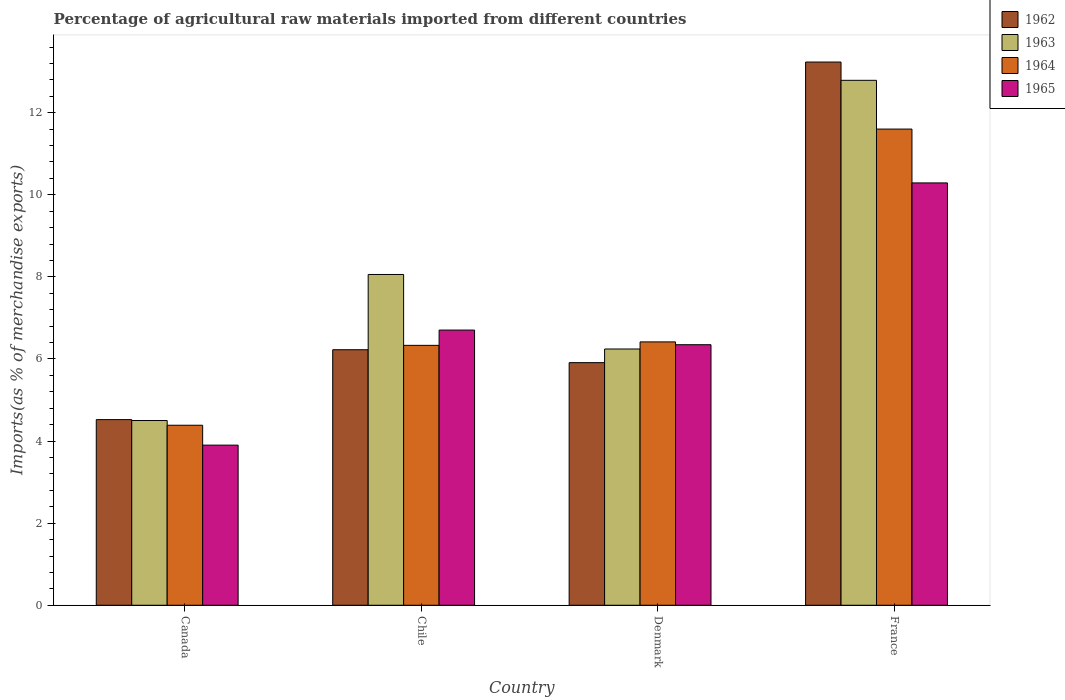Are the number of bars per tick equal to the number of legend labels?
Your answer should be compact. Yes. Are the number of bars on each tick of the X-axis equal?
Your answer should be very brief. Yes. How many bars are there on the 3rd tick from the left?
Your response must be concise. 4. What is the percentage of imports to different countries in 1965 in Chile?
Give a very brief answer. 6.7. Across all countries, what is the maximum percentage of imports to different countries in 1965?
Ensure brevity in your answer.  10.29. Across all countries, what is the minimum percentage of imports to different countries in 1964?
Your answer should be compact. 4.39. What is the total percentage of imports to different countries in 1962 in the graph?
Provide a succinct answer. 29.9. What is the difference between the percentage of imports to different countries in 1962 in Chile and that in Denmark?
Your answer should be very brief. 0.31. What is the difference between the percentage of imports to different countries in 1965 in France and the percentage of imports to different countries in 1964 in Chile?
Your response must be concise. 3.96. What is the average percentage of imports to different countries in 1965 per country?
Ensure brevity in your answer.  6.81. What is the difference between the percentage of imports to different countries of/in 1963 and percentage of imports to different countries of/in 1964 in France?
Your answer should be compact. 1.19. What is the ratio of the percentage of imports to different countries in 1962 in Chile to that in Denmark?
Provide a succinct answer. 1.05. Is the percentage of imports to different countries in 1963 in Denmark less than that in France?
Your answer should be compact. Yes. What is the difference between the highest and the second highest percentage of imports to different countries in 1965?
Keep it short and to the point. 3.59. What is the difference between the highest and the lowest percentage of imports to different countries in 1964?
Your answer should be very brief. 7.22. In how many countries, is the percentage of imports to different countries in 1964 greater than the average percentage of imports to different countries in 1964 taken over all countries?
Keep it short and to the point. 1. What does the 4th bar from the left in France represents?
Offer a terse response. 1965. What does the 2nd bar from the right in Chile represents?
Provide a short and direct response. 1964. How many bars are there?
Your answer should be very brief. 16. What is the difference between two consecutive major ticks on the Y-axis?
Your answer should be very brief. 2. Does the graph contain grids?
Offer a very short reply. No. Where does the legend appear in the graph?
Make the answer very short. Top right. What is the title of the graph?
Offer a terse response. Percentage of agricultural raw materials imported from different countries. What is the label or title of the X-axis?
Your answer should be very brief. Country. What is the label or title of the Y-axis?
Offer a terse response. Imports(as % of merchandise exports). What is the Imports(as % of merchandise exports) in 1962 in Canada?
Your answer should be very brief. 4.52. What is the Imports(as % of merchandise exports) of 1963 in Canada?
Your response must be concise. 4.5. What is the Imports(as % of merchandise exports) of 1964 in Canada?
Offer a very short reply. 4.39. What is the Imports(as % of merchandise exports) of 1965 in Canada?
Make the answer very short. 3.9. What is the Imports(as % of merchandise exports) of 1962 in Chile?
Provide a short and direct response. 6.23. What is the Imports(as % of merchandise exports) in 1963 in Chile?
Give a very brief answer. 8.06. What is the Imports(as % of merchandise exports) of 1964 in Chile?
Provide a short and direct response. 6.33. What is the Imports(as % of merchandise exports) of 1965 in Chile?
Provide a succinct answer. 6.7. What is the Imports(as % of merchandise exports) in 1962 in Denmark?
Give a very brief answer. 5.91. What is the Imports(as % of merchandise exports) of 1963 in Denmark?
Your answer should be very brief. 6.24. What is the Imports(as % of merchandise exports) in 1964 in Denmark?
Give a very brief answer. 6.42. What is the Imports(as % of merchandise exports) in 1965 in Denmark?
Make the answer very short. 6.35. What is the Imports(as % of merchandise exports) of 1962 in France?
Ensure brevity in your answer.  13.24. What is the Imports(as % of merchandise exports) of 1963 in France?
Offer a terse response. 12.79. What is the Imports(as % of merchandise exports) in 1964 in France?
Your response must be concise. 11.6. What is the Imports(as % of merchandise exports) of 1965 in France?
Ensure brevity in your answer.  10.29. Across all countries, what is the maximum Imports(as % of merchandise exports) in 1962?
Your answer should be very brief. 13.24. Across all countries, what is the maximum Imports(as % of merchandise exports) of 1963?
Provide a succinct answer. 12.79. Across all countries, what is the maximum Imports(as % of merchandise exports) in 1964?
Provide a succinct answer. 11.6. Across all countries, what is the maximum Imports(as % of merchandise exports) of 1965?
Give a very brief answer. 10.29. Across all countries, what is the minimum Imports(as % of merchandise exports) of 1962?
Your response must be concise. 4.52. Across all countries, what is the minimum Imports(as % of merchandise exports) in 1963?
Give a very brief answer. 4.5. Across all countries, what is the minimum Imports(as % of merchandise exports) in 1964?
Your answer should be compact. 4.39. Across all countries, what is the minimum Imports(as % of merchandise exports) in 1965?
Make the answer very short. 3.9. What is the total Imports(as % of merchandise exports) in 1962 in the graph?
Offer a terse response. 29.9. What is the total Imports(as % of merchandise exports) of 1963 in the graph?
Your response must be concise. 31.59. What is the total Imports(as % of merchandise exports) of 1964 in the graph?
Your response must be concise. 28.74. What is the total Imports(as % of merchandise exports) of 1965 in the graph?
Your answer should be very brief. 27.24. What is the difference between the Imports(as % of merchandise exports) in 1962 in Canada and that in Chile?
Keep it short and to the point. -1.7. What is the difference between the Imports(as % of merchandise exports) of 1963 in Canada and that in Chile?
Your answer should be very brief. -3.56. What is the difference between the Imports(as % of merchandise exports) in 1964 in Canada and that in Chile?
Make the answer very short. -1.95. What is the difference between the Imports(as % of merchandise exports) in 1965 in Canada and that in Chile?
Your answer should be compact. -2.8. What is the difference between the Imports(as % of merchandise exports) of 1962 in Canada and that in Denmark?
Offer a very short reply. -1.39. What is the difference between the Imports(as % of merchandise exports) of 1963 in Canada and that in Denmark?
Ensure brevity in your answer.  -1.74. What is the difference between the Imports(as % of merchandise exports) in 1964 in Canada and that in Denmark?
Provide a short and direct response. -2.03. What is the difference between the Imports(as % of merchandise exports) of 1965 in Canada and that in Denmark?
Provide a succinct answer. -2.45. What is the difference between the Imports(as % of merchandise exports) in 1962 in Canada and that in France?
Provide a short and direct response. -8.71. What is the difference between the Imports(as % of merchandise exports) in 1963 in Canada and that in France?
Your answer should be compact. -8.29. What is the difference between the Imports(as % of merchandise exports) in 1964 in Canada and that in France?
Your answer should be very brief. -7.22. What is the difference between the Imports(as % of merchandise exports) of 1965 in Canada and that in France?
Your response must be concise. -6.39. What is the difference between the Imports(as % of merchandise exports) in 1962 in Chile and that in Denmark?
Provide a succinct answer. 0.31. What is the difference between the Imports(as % of merchandise exports) in 1963 in Chile and that in Denmark?
Keep it short and to the point. 1.82. What is the difference between the Imports(as % of merchandise exports) of 1964 in Chile and that in Denmark?
Provide a short and direct response. -0.08. What is the difference between the Imports(as % of merchandise exports) of 1965 in Chile and that in Denmark?
Offer a terse response. 0.36. What is the difference between the Imports(as % of merchandise exports) of 1962 in Chile and that in France?
Ensure brevity in your answer.  -7.01. What is the difference between the Imports(as % of merchandise exports) in 1963 in Chile and that in France?
Ensure brevity in your answer.  -4.73. What is the difference between the Imports(as % of merchandise exports) of 1964 in Chile and that in France?
Give a very brief answer. -5.27. What is the difference between the Imports(as % of merchandise exports) in 1965 in Chile and that in France?
Your response must be concise. -3.59. What is the difference between the Imports(as % of merchandise exports) of 1962 in Denmark and that in France?
Offer a very short reply. -7.32. What is the difference between the Imports(as % of merchandise exports) in 1963 in Denmark and that in France?
Provide a short and direct response. -6.55. What is the difference between the Imports(as % of merchandise exports) of 1964 in Denmark and that in France?
Your answer should be very brief. -5.19. What is the difference between the Imports(as % of merchandise exports) of 1965 in Denmark and that in France?
Your answer should be compact. -3.94. What is the difference between the Imports(as % of merchandise exports) of 1962 in Canada and the Imports(as % of merchandise exports) of 1963 in Chile?
Keep it short and to the point. -3.54. What is the difference between the Imports(as % of merchandise exports) in 1962 in Canada and the Imports(as % of merchandise exports) in 1964 in Chile?
Your response must be concise. -1.81. What is the difference between the Imports(as % of merchandise exports) in 1962 in Canada and the Imports(as % of merchandise exports) in 1965 in Chile?
Give a very brief answer. -2.18. What is the difference between the Imports(as % of merchandise exports) of 1963 in Canada and the Imports(as % of merchandise exports) of 1964 in Chile?
Offer a terse response. -1.83. What is the difference between the Imports(as % of merchandise exports) in 1963 in Canada and the Imports(as % of merchandise exports) in 1965 in Chile?
Make the answer very short. -2.2. What is the difference between the Imports(as % of merchandise exports) of 1964 in Canada and the Imports(as % of merchandise exports) of 1965 in Chile?
Your response must be concise. -2.32. What is the difference between the Imports(as % of merchandise exports) in 1962 in Canada and the Imports(as % of merchandise exports) in 1963 in Denmark?
Make the answer very short. -1.72. What is the difference between the Imports(as % of merchandise exports) in 1962 in Canada and the Imports(as % of merchandise exports) in 1964 in Denmark?
Provide a succinct answer. -1.89. What is the difference between the Imports(as % of merchandise exports) of 1962 in Canada and the Imports(as % of merchandise exports) of 1965 in Denmark?
Provide a short and direct response. -1.83. What is the difference between the Imports(as % of merchandise exports) of 1963 in Canada and the Imports(as % of merchandise exports) of 1964 in Denmark?
Keep it short and to the point. -1.92. What is the difference between the Imports(as % of merchandise exports) of 1963 in Canada and the Imports(as % of merchandise exports) of 1965 in Denmark?
Offer a very short reply. -1.85. What is the difference between the Imports(as % of merchandise exports) in 1964 in Canada and the Imports(as % of merchandise exports) in 1965 in Denmark?
Keep it short and to the point. -1.96. What is the difference between the Imports(as % of merchandise exports) of 1962 in Canada and the Imports(as % of merchandise exports) of 1963 in France?
Give a very brief answer. -8.27. What is the difference between the Imports(as % of merchandise exports) of 1962 in Canada and the Imports(as % of merchandise exports) of 1964 in France?
Provide a succinct answer. -7.08. What is the difference between the Imports(as % of merchandise exports) of 1962 in Canada and the Imports(as % of merchandise exports) of 1965 in France?
Your response must be concise. -5.77. What is the difference between the Imports(as % of merchandise exports) of 1963 in Canada and the Imports(as % of merchandise exports) of 1964 in France?
Offer a very short reply. -7.1. What is the difference between the Imports(as % of merchandise exports) in 1963 in Canada and the Imports(as % of merchandise exports) in 1965 in France?
Offer a very short reply. -5.79. What is the difference between the Imports(as % of merchandise exports) in 1964 in Canada and the Imports(as % of merchandise exports) in 1965 in France?
Your answer should be compact. -5.9. What is the difference between the Imports(as % of merchandise exports) of 1962 in Chile and the Imports(as % of merchandise exports) of 1963 in Denmark?
Your response must be concise. -0.02. What is the difference between the Imports(as % of merchandise exports) of 1962 in Chile and the Imports(as % of merchandise exports) of 1964 in Denmark?
Ensure brevity in your answer.  -0.19. What is the difference between the Imports(as % of merchandise exports) in 1962 in Chile and the Imports(as % of merchandise exports) in 1965 in Denmark?
Your response must be concise. -0.12. What is the difference between the Imports(as % of merchandise exports) in 1963 in Chile and the Imports(as % of merchandise exports) in 1964 in Denmark?
Make the answer very short. 1.64. What is the difference between the Imports(as % of merchandise exports) of 1963 in Chile and the Imports(as % of merchandise exports) of 1965 in Denmark?
Provide a short and direct response. 1.71. What is the difference between the Imports(as % of merchandise exports) of 1964 in Chile and the Imports(as % of merchandise exports) of 1965 in Denmark?
Your answer should be very brief. -0.02. What is the difference between the Imports(as % of merchandise exports) of 1962 in Chile and the Imports(as % of merchandise exports) of 1963 in France?
Give a very brief answer. -6.56. What is the difference between the Imports(as % of merchandise exports) in 1962 in Chile and the Imports(as % of merchandise exports) in 1964 in France?
Your answer should be very brief. -5.38. What is the difference between the Imports(as % of merchandise exports) of 1962 in Chile and the Imports(as % of merchandise exports) of 1965 in France?
Keep it short and to the point. -4.06. What is the difference between the Imports(as % of merchandise exports) in 1963 in Chile and the Imports(as % of merchandise exports) in 1964 in France?
Give a very brief answer. -3.54. What is the difference between the Imports(as % of merchandise exports) of 1963 in Chile and the Imports(as % of merchandise exports) of 1965 in France?
Ensure brevity in your answer.  -2.23. What is the difference between the Imports(as % of merchandise exports) of 1964 in Chile and the Imports(as % of merchandise exports) of 1965 in France?
Your answer should be compact. -3.96. What is the difference between the Imports(as % of merchandise exports) in 1962 in Denmark and the Imports(as % of merchandise exports) in 1963 in France?
Your response must be concise. -6.88. What is the difference between the Imports(as % of merchandise exports) in 1962 in Denmark and the Imports(as % of merchandise exports) in 1964 in France?
Offer a very short reply. -5.69. What is the difference between the Imports(as % of merchandise exports) in 1962 in Denmark and the Imports(as % of merchandise exports) in 1965 in France?
Ensure brevity in your answer.  -4.38. What is the difference between the Imports(as % of merchandise exports) in 1963 in Denmark and the Imports(as % of merchandise exports) in 1964 in France?
Your answer should be very brief. -5.36. What is the difference between the Imports(as % of merchandise exports) of 1963 in Denmark and the Imports(as % of merchandise exports) of 1965 in France?
Your answer should be very brief. -4.05. What is the difference between the Imports(as % of merchandise exports) of 1964 in Denmark and the Imports(as % of merchandise exports) of 1965 in France?
Offer a terse response. -3.87. What is the average Imports(as % of merchandise exports) of 1962 per country?
Offer a terse response. 7.47. What is the average Imports(as % of merchandise exports) in 1963 per country?
Your response must be concise. 7.9. What is the average Imports(as % of merchandise exports) of 1964 per country?
Your answer should be very brief. 7.18. What is the average Imports(as % of merchandise exports) of 1965 per country?
Provide a succinct answer. 6.81. What is the difference between the Imports(as % of merchandise exports) in 1962 and Imports(as % of merchandise exports) in 1963 in Canada?
Keep it short and to the point. 0.02. What is the difference between the Imports(as % of merchandise exports) in 1962 and Imports(as % of merchandise exports) in 1964 in Canada?
Your answer should be very brief. 0.14. What is the difference between the Imports(as % of merchandise exports) of 1962 and Imports(as % of merchandise exports) of 1965 in Canada?
Ensure brevity in your answer.  0.62. What is the difference between the Imports(as % of merchandise exports) in 1963 and Imports(as % of merchandise exports) in 1964 in Canada?
Provide a short and direct response. 0.12. What is the difference between the Imports(as % of merchandise exports) of 1963 and Imports(as % of merchandise exports) of 1965 in Canada?
Ensure brevity in your answer.  0.6. What is the difference between the Imports(as % of merchandise exports) in 1964 and Imports(as % of merchandise exports) in 1965 in Canada?
Provide a short and direct response. 0.48. What is the difference between the Imports(as % of merchandise exports) of 1962 and Imports(as % of merchandise exports) of 1963 in Chile?
Offer a terse response. -1.83. What is the difference between the Imports(as % of merchandise exports) in 1962 and Imports(as % of merchandise exports) in 1964 in Chile?
Keep it short and to the point. -0.11. What is the difference between the Imports(as % of merchandise exports) of 1962 and Imports(as % of merchandise exports) of 1965 in Chile?
Provide a succinct answer. -0.48. What is the difference between the Imports(as % of merchandise exports) of 1963 and Imports(as % of merchandise exports) of 1964 in Chile?
Give a very brief answer. 1.73. What is the difference between the Imports(as % of merchandise exports) in 1963 and Imports(as % of merchandise exports) in 1965 in Chile?
Offer a very short reply. 1.35. What is the difference between the Imports(as % of merchandise exports) of 1964 and Imports(as % of merchandise exports) of 1965 in Chile?
Provide a short and direct response. -0.37. What is the difference between the Imports(as % of merchandise exports) of 1962 and Imports(as % of merchandise exports) of 1963 in Denmark?
Your answer should be very brief. -0.33. What is the difference between the Imports(as % of merchandise exports) of 1962 and Imports(as % of merchandise exports) of 1964 in Denmark?
Make the answer very short. -0.51. What is the difference between the Imports(as % of merchandise exports) of 1962 and Imports(as % of merchandise exports) of 1965 in Denmark?
Ensure brevity in your answer.  -0.44. What is the difference between the Imports(as % of merchandise exports) of 1963 and Imports(as % of merchandise exports) of 1964 in Denmark?
Provide a short and direct response. -0.17. What is the difference between the Imports(as % of merchandise exports) in 1963 and Imports(as % of merchandise exports) in 1965 in Denmark?
Make the answer very short. -0.1. What is the difference between the Imports(as % of merchandise exports) of 1964 and Imports(as % of merchandise exports) of 1965 in Denmark?
Provide a short and direct response. 0.07. What is the difference between the Imports(as % of merchandise exports) in 1962 and Imports(as % of merchandise exports) in 1963 in France?
Your answer should be compact. 0.45. What is the difference between the Imports(as % of merchandise exports) in 1962 and Imports(as % of merchandise exports) in 1964 in France?
Your response must be concise. 1.63. What is the difference between the Imports(as % of merchandise exports) in 1962 and Imports(as % of merchandise exports) in 1965 in France?
Ensure brevity in your answer.  2.95. What is the difference between the Imports(as % of merchandise exports) of 1963 and Imports(as % of merchandise exports) of 1964 in France?
Give a very brief answer. 1.19. What is the difference between the Imports(as % of merchandise exports) of 1963 and Imports(as % of merchandise exports) of 1965 in France?
Offer a terse response. 2.5. What is the difference between the Imports(as % of merchandise exports) of 1964 and Imports(as % of merchandise exports) of 1965 in France?
Make the answer very short. 1.31. What is the ratio of the Imports(as % of merchandise exports) in 1962 in Canada to that in Chile?
Make the answer very short. 0.73. What is the ratio of the Imports(as % of merchandise exports) of 1963 in Canada to that in Chile?
Your answer should be compact. 0.56. What is the ratio of the Imports(as % of merchandise exports) in 1964 in Canada to that in Chile?
Your answer should be very brief. 0.69. What is the ratio of the Imports(as % of merchandise exports) of 1965 in Canada to that in Chile?
Your response must be concise. 0.58. What is the ratio of the Imports(as % of merchandise exports) of 1962 in Canada to that in Denmark?
Your answer should be compact. 0.77. What is the ratio of the Imports(as % of merchandise exports) of 1963 in Canada to that in Denmark?
Give a very brief answer. 0.72. What is the ratio of the Imports(as % of merchandise exports) of 1964 in Canada to that in Denmark?
Ensure brevity in your answer.  0.68. What is the ratio of the Imports(as % of merchandise exports) of 1965 in Canada to that in Denmark?
Offer a terse response. 0.61. What is the ratio of the Imports(as % of merchandise exports) of 1962 in Canada to that in France?
Offer a very short reply. 0.34. What is the ratio of the Imports(as % of merchandise exports) of 1963 in Canada to that in France?
Offer a terse response. 0.35. What is the ratio of the Imports(as % of merchandise exports) in 1964 in Canada to that in France?
Your answer should be compact. 0.38. What is the ratio of the Imports(as % of merchandise exports) in 1965 in Canada to that in France?
Ensure brevity in your answer.  0.38. What is the ratio of the Imports(as % of merchandise exports) in 1962 in Chile to that in Denmark?
Provide a succinct answer. 1.05. What is the ratio of the Imports(as % of merchandise exports) in 1963 in Chile to that in Denmark?
Provide a short and direct response. 1.29. What is the ratio of the Imports(as % of merchandise exports) in 1964 in Chile to that in Denmark?
Your answer should be compact. 0.99. What is the ratio of the Imports(as % of merchandise exports) in 1965 in Chile to that in Denmark?
Make the answer very short. 1.06. What is the ratio of the Imports(as % of merchandise exports) in 1962 in Chile to that in France?
Make the answer very short. 0.47. What is the ratio of the Imports(as % of merchandise exports) in 1963 in Chile to that in France?
Your answer should be compact. 0.63. What is the ratio of the Imports(as % of merchandise exports) of 1964 in Chile to that in France?
Keep it short and to the point. 0.55. What is the ratio of the Imports(as % of merchandise exports) in 1965 in Chile to that in France?
Your answer should be very brief. 0.65. What is the ratio of the Imports(as % of merchandise exports) in 1962 in Denmark to that in France?
Your answer should be compact. 0.45. What is the ratio of the Imports(as % of merchandise exports) in 1963 in Denmark to that in France?
Offer a very short reply. 0.49. What is the ratio of the Imports(as % of merchandise exports) of 1964 in Denmark to that in France?
Give a very brief answer. 0.55. What is the ratio of the Imports(as % of merchandise exports) in 1965 in Denmark to that in France?
Give a very brief answer. 0.62. What is the difference between the highest and the second highest Imports(as % of merchandise exports) of 1962?
Make the answer very short. 7.01. What is the difference between the highest and the second highest Imports(as % of merchandise exports) in 1963?
Your answer should be very brief. 4.73. What is the difference between the highest and the second highest Imports(as % of merchandise exports) in 1964?
Keep it short and to the point. 5.19. What is the difference between the highest and the second highest Imports(as % of merchandise exports) in 1965?
Keep it short and to the point. 3.59. What is the difference between the highest and the lowest Imports(as % of merchandise exports) of 1962?
Ensure brevity in your answer.  8.71. What is the difference between the highest and the lowest Imports(as % of merchandise exports) in 1963?
Your answer should be compact. 8.29. What is the difference between the highest and the lowest Imports(as % of merchandise exports) of 1964?
Offer a very short reply. 7.22. What is the difference between the highest and the lowest Imports(as % of merchandise exports) of 1965?
Your response must be concise. 6.39. 